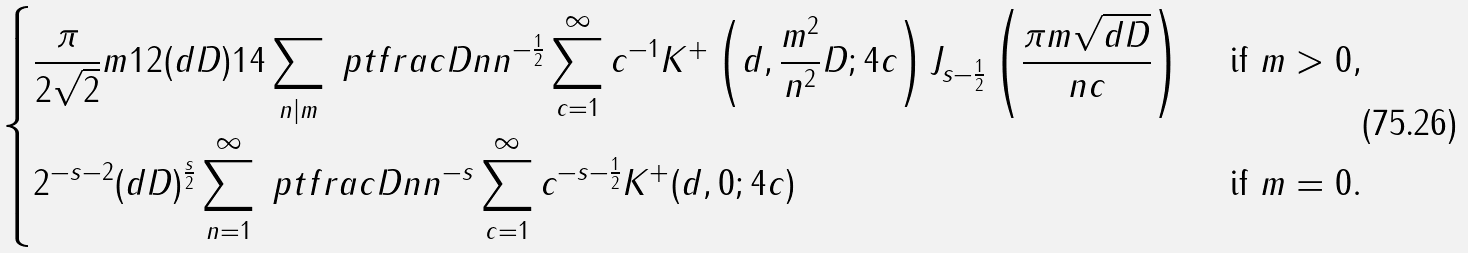Convert formula to latex. <formula><loc_0><loc_0><loc_500><loc_500>\begin{dcases} \frac { \pi } { 2 \sqrt { 2 } } m ^ { } { 1 } 2 ( d D ) ^ { } { 1 } 4 \sum _ { n | m } \ p t f r a c D n n ^ { - \frac { 1 } { 2 } } \sum _ { c = 1 } ^ { \infty } c ^ { - 1 } K ^ { + } \left ( d , \frac { m ^ { 2 } } { n ^ { 2 } } D ; 4 c \right ) J _ { s - \frac { 1 } { 2 } } \left ( \frac { \pi m \sqrt { d D } } { n c } \right ) & \text { if } m > 0 , \\ 2 ^ { - s - 2 } ( d D ) ^ { \frac { s } { 2 } } \sum _ { n = 1 } ^ { \infty } \ p t f r a c D n n ^ { - s } \sum _ { c = 1 } ^ { \infty } c ^ { - s - \frac { 1 } { 2 } } K ^ { + } ( d , 0 ; 4 c ) & \text { if } m = 0 . \end{dcases}</formula> 